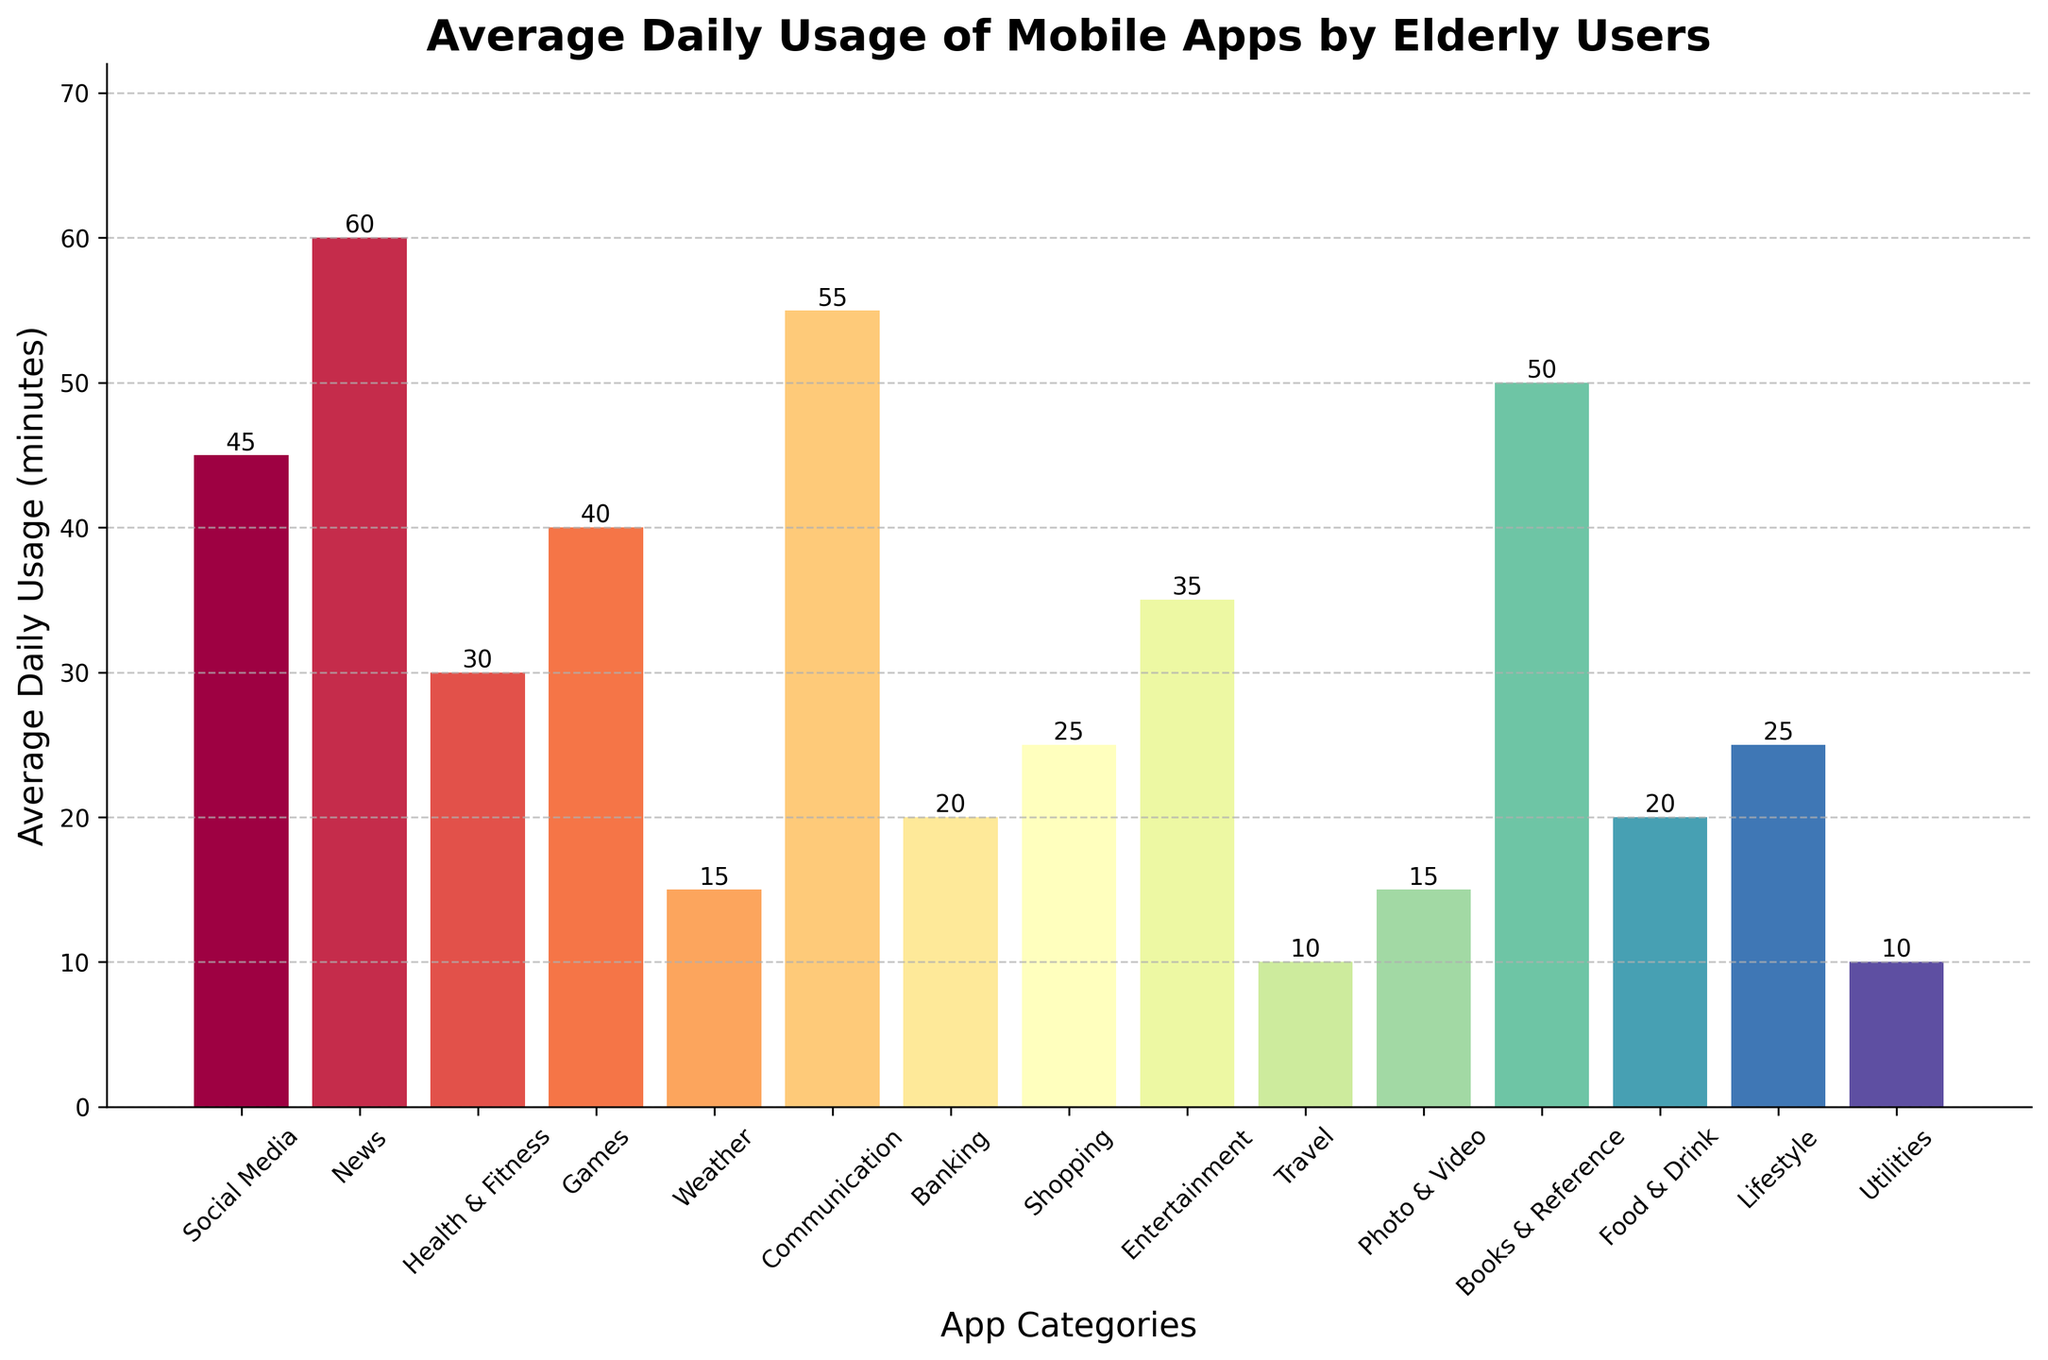Which app category do elderly users spend the most time on daily? By looking at the height of the bars, the News category has the tallest bar, indicating it has the highest average daily usage.
Answer: News Which two app categories have the equal lowest average daily usage? Both the Weather and Travel categories have bars of equal height at the lowest level of 10 minutes, indicating they are the lowest in average daily use.
Answer: Weather, Travel What is the combined daily usage for Books & Reference and Communication apps? The average daily usage for Books & Reference is 50 minutes, and for Communication, it is 55 minutes. Combined, they sum up to 105 minutes.
Answer: 105 minutes How does the average time spent on Social Media compare to Entertainment apps? The bar height for Social Media is 45 minutes, and for Entertainment, it is 35 minutes. Thus, Social Media usage is 10 minutes higher than Entertainment.
Answer: 10 minutes higher What is the difference in average daily usage between News and Banking apps? The average daily usage for News is 60 minutes, while for Banking, it is 20 minutes. The difference is 60 - 20 = 40 minutes.
Answer: 40 minutes Sort the three app categories with the highest daily usage in descending order. The three highest bars represent News (60 minutes), Communication (55 minutes), and Books & Reference (50 minutes). Therefore, in descending order: News, Communication, Books & Reference.
Answer: News, Communication, Books & Reference How many app categories have a daily usage of 25 minutes or more? By checking the bars with heights of 25 minutes or above: Social Media (45), News (60), Health & Fitness (30), Games (40), Entertainment (35), Communication (55), Photo & Video (15 - not included), Banking (20 - not included), Books & Reference (50), Food & Drink (20 - not included), Lifestyle (25). We find 7 categories that meet the criteria.
Answer: 7 What is the average daily usage across all categories? Summing all usage values: 45 + 60 + 30 + 40 + 15 + 55 + 20 + 25 + 35 + 10 + 15 + 50 + 20 + 25 + 10 = 455 minutes. There are 15 categories. The average is 455 / 15 = 30.33 minutes.
Answer: 30.33 minutes What fraction of the total daily usage is spent on Games? The total daily usage is 455 minutes and Games account for 40 minutes. The fraction is 40 / 455 ≈ 0.0879.
Answer: Approximately 0.0879 